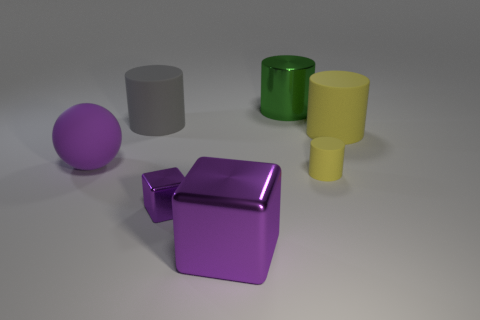What is the shape of the big yellow matte object?
Your answer should be very brief. Cylinder. Are there more large yellow cylinders left of the big green metallic cylinder than large gray rubber objects that are left of the large matte sphere?
Provide a succinct answer. No. What number of other objects are there of the same size as the purple matte ball?
Provide a succinct answer. 4. There is a thing that is both to the right of the big green cylinder and in front of the large sphere; what is it made of?
Provide a succinct answer. Rubber. There is a small yellow thing that is the same shape as the big gray matte thing; what is its material?
Give a very brief answer. Rubber. How many matte cylinders are left of the purple object that is to the right of the purple metallic thing behind the large cube?
Your answer should be very brief. 1. Is there any other thing of the same color as the tiny shiny cube?
Offer a terse response. Yes. What number of yellow things are behind the large purple matte thing and in front of the large ball?
Provide a short and direct response. 0. There is a rubber cylinder left of the large green cylinder; is it the same size as the metallic cube behind the large purple shiny cube?
Provide a short and direct response. No. How many things are either metallic things in front of the matte sphere or tiny shiny cubes?
Your answer should be very brief. 2. 